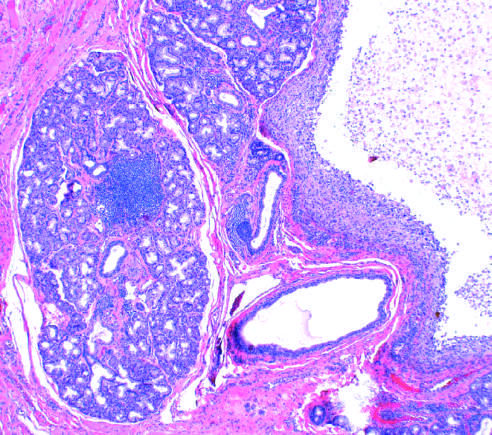re the lower lobe seen on the left?
Answer the question using a single word or phrase. No 